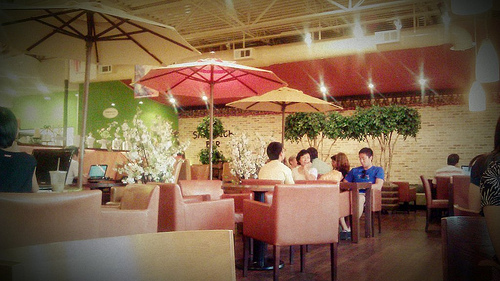What's the atmosphere of the place shown in the image? The image presents a casual and relaxed dining environment with an indoor setting that mimics an outdoor cafe ambiance, complete with table umbrellas and warm, inviting colors. Are there any decorations visible? Yes, there are decorative elements like potted plants, a brick wall that adds a rustic charm, and umbrellas suggesting a terrace-like feel. 